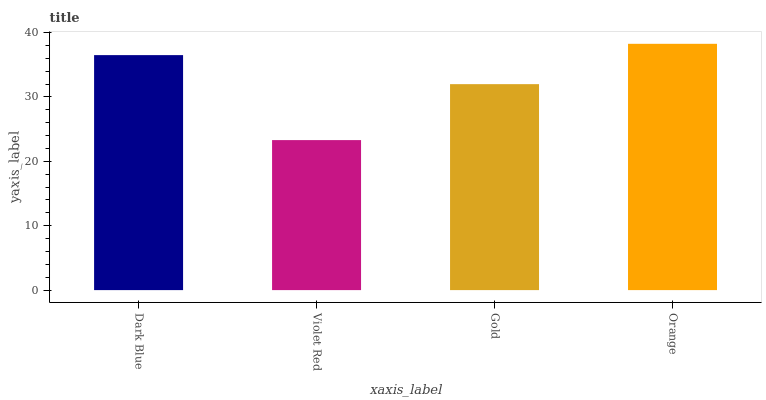Is Violet Red the minimum?
Answer yes or no. Yes. Is Orange the maximum?
Answer yes or no. Yes. Is Gold the minimum?
Answer yes or no. No. Is Gold the maximum?
Answer yes or no. No. Is Gold greater than Violet Red?
Answer yes or no. Yes. Is Violet Red less than Gold?
Answer yes or no. Yes. Is Violet Red greater than Gold?
Answer yes or no. No. Is Gold less than Violet Red?
Answer yes or no. No. Is Dark Blue the high median?
Answer yes or no. Yes. Is Gold the low median?
Answer yes or no. Yes. Is Gold the high median?
Answer yes or no. No. Is Violet Red the low median?
Answer yes or no. No. 